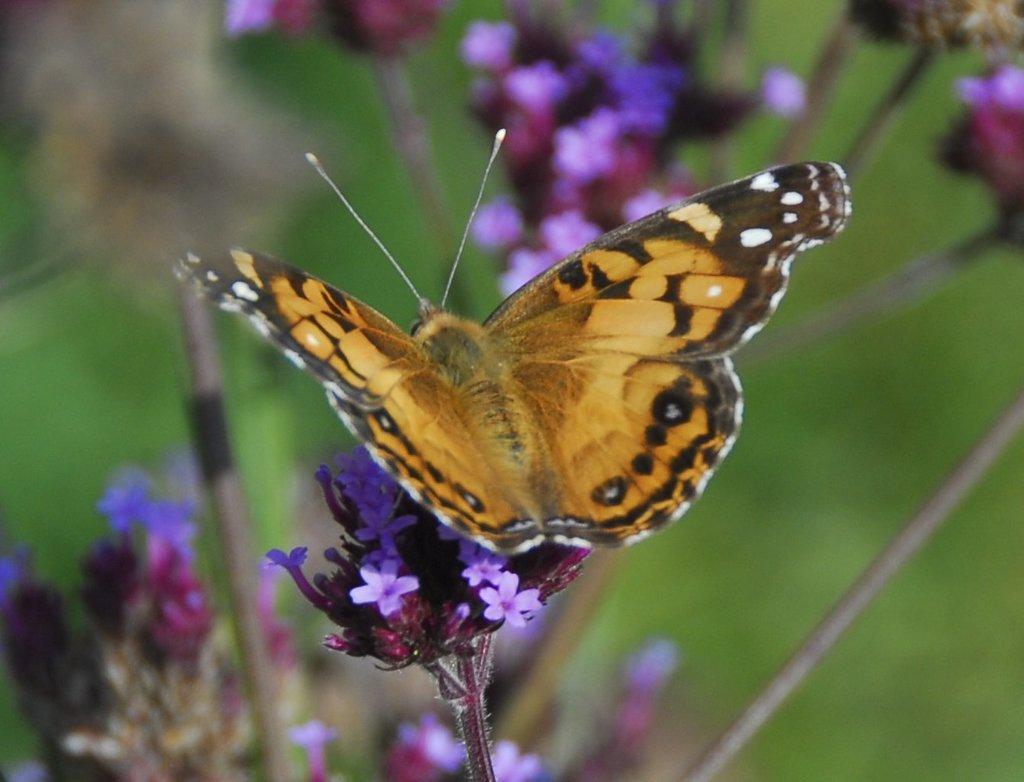Describe this image in one or two sentences. In the middle I can see a butterfly on flowering plants and grass. This image is taken may be in a garden during a day. 